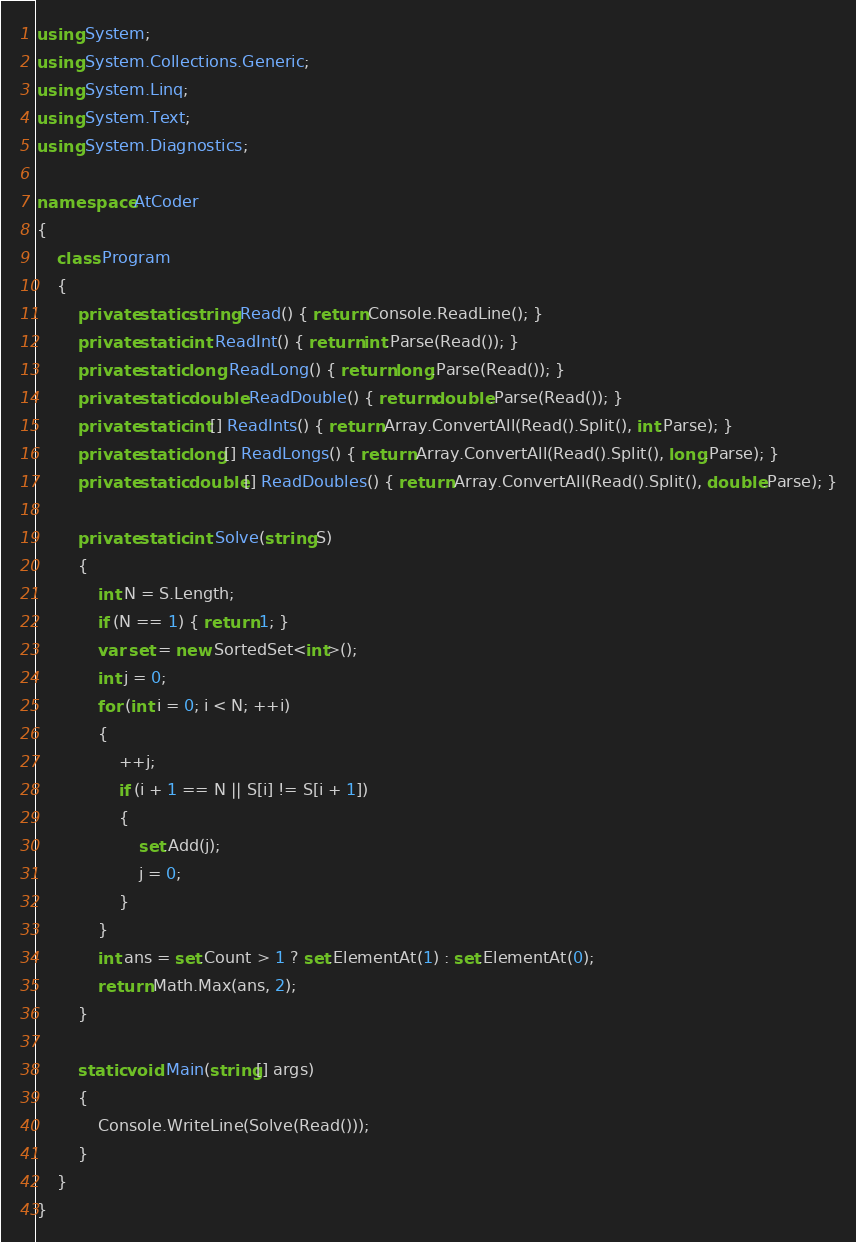Convert code to text. <code><loc_0><loc_0><loc_500><loc_500><_C#_>using System;
using System.Collections.Generic;
using System.Linq;
using System.Text;
using System.Diagnostics;

namespace AtCoder
{
    class Program
    {
        private static string Read() { return Console.ReadLine(); }
        private static int ReadInt() { return int.Parse(Read()); }
        private static long ReadLong() { return long.Parse(Read()); }
        private static double ReadDouble() { return double.Parse(Read()); }
        private static int[] ReadInts() { return Array.ConvertAll(Read().Split(), int.Parse); }
        private static long[] ReadLongs() { return Array.ConvertAll(Read().Split(), long.Parse); }
        private static double[] ReadDoubles() { return Array.ConvertAll(Read().Split(), double.Parse); }

        private static int Solve(string S)
        {
            int N = S.Length;
            if (N == 1) { return 1; }
            var set = new SortedSet<int>();
            int j = 0;
            for (int i = 0; i < N; ++i)
            {
                ++j;
                if (i + 1 == N || S[i] != S[i + 1])
                {
                    set.Add(j);
                    j = 0;
                }
            }
            int ans = set.Count > 1 ? set.ElementAt(1) : set.ElementAt(0);
            return Math.Max(ans, 2);
        }

        static void Main(string[] args)
        {
            Console.WriteLine(Solve(Read()));
        }
    }
}
</code> 